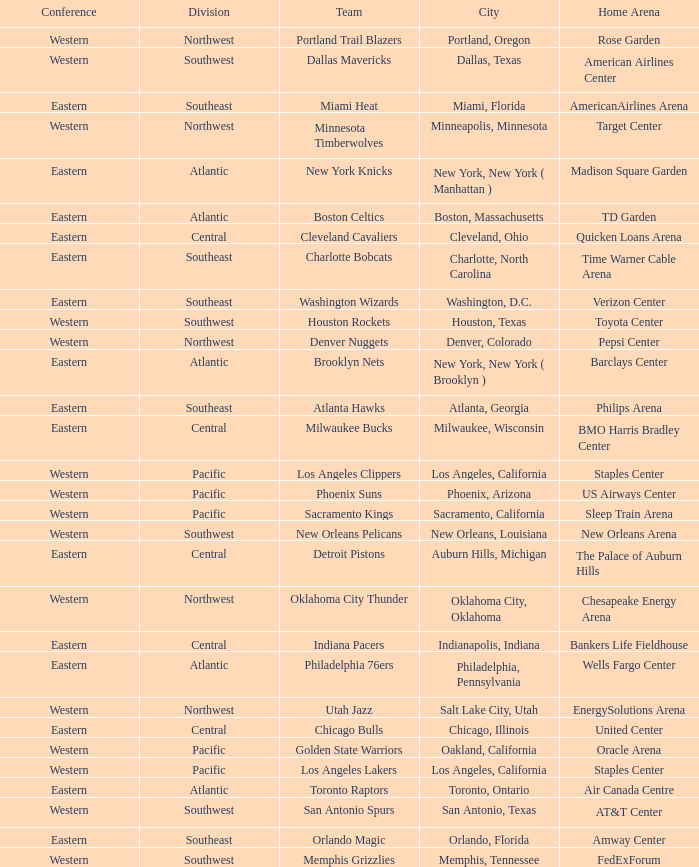Which conference is in Portland, Oregon? Western. 